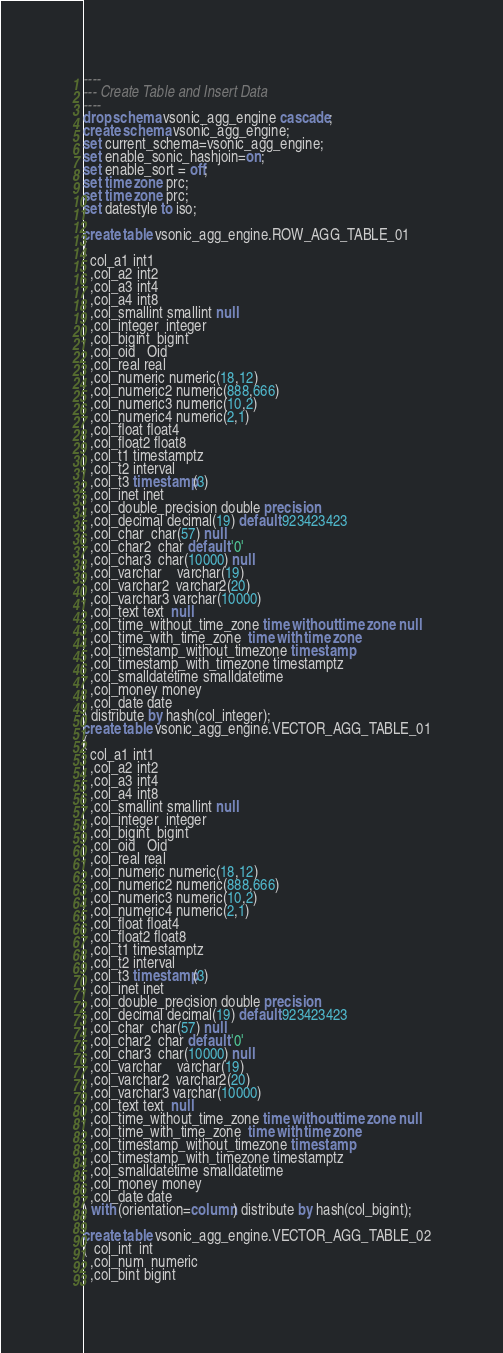<code> <loc_0><loc_0><loc_500><loc_500><_SQL_>

----
--- Create Table and Insert Data
----
drop schema vsonic_agg_engine cascade;
create schema vsonic_agg_engine;
set current_schema=vsonic_agg_engine;
set enable_sonic_hashjoin=on;
set enable_sort = off;
set time zone prc;
set time zone prc;
set datestyle to iso;

create table vsonic_agg_engine.ROW_AGG_TABLE_01
( 
  col_a1 int1
  ,col_a2 int2
  ,col_a3 int4
  ,col_a4 int8
  ,col_smallint smallint null
  ,col_integer  integer  
  ,col_bigint  bigint  
  ,col_oid   Oid
  ,col_real real 
  ,col_numeric numeric(18,12) 
  ,col_numeric2 numeric(888,666) 
  ,col_numeric3 numeric(10,2) 
  ,col_numeric4 numeric(2,1) 
  ,col_float float4
  ,col_float2 float8
  ,col_t1 timestamptz
  ,col_t2 interval
  ,col_t3 timestamp(3)
  ,col_inet inet
  ,col_double_precision double precision
  ,col_decimal decimal(19) default 923423423
  ,col_char  char(57) null
  ,col_char2  char default '0'
  ,col_char3  char(10000) null
  ,col_varchar 	varchar(19)
  ,col_varchar2  varchar2(20)
  ,col_varchar3 varchar(10000)
  ,col_text text  null
  ,col_time_without_time_zone time without time zone null
  ,col_time_with_time_zone  time with time zone
  ,col_timestamp_without_timezone timestamp
  ,col_timestamp_with_timezone timestamptz
  ,col_smalldatetime smalldatetime
  ,col_money money
  ,col_date date
) distribute by hash(col_integer);
create table vsonic_agg_engine.VECTOR_AGG_TABLE_01
( 
  col_a1 int1
  ,col_a2 int2
  ,col_a3 int4
  ,col_a4 int8
  ,col_smallint smallint null
  ,col_integer  integer  
  ,col_bigint  bigint  
  ,col_oid   Oid
  ,col_real real 
  ,col_numeric numeric(18,12) 
  ,col_numeric2 numeric(888,666) 
  ,col_numeric3 numeric(10,2) 
  ,col_numeric4 numeric(2,1) 
  ,col_float float4
  ,col_float2 float8
  ,col_t1 timestamptz
  ,col_t2 interval
  ,col_t3 timestamp(3)
  ,col_inet inet
  ,col_double_precision double precision
  ,col_decimal decimal(19) default 923423423
  ,col_char  char(57) null
  ,col_char2  char default '0'
  ,col_char3  char(10000) null
  ,col_varchar 	varchar(19)
  ,col_varchar2  varchar2(20)
  ,col_varchar3 varchar(10000)
  ,col_text text  null
  ,col_time_without_time_zone time without time zone null
  ,col_time_with_time_zone  time with time zone
  ,col_timestamp_without_timezone timestamp
  ,col_timestamp_with_timezone timestamptz
  ,col_smalldatetime smalldatetime
  ,col_money money
  ,col_date date
) with (orientation=column) distribute by hash(col_bigint);

create table vsonic_agg_engine.VECTOR_AGG_TABLE_02
(  col_int  int
  ,col_num  numeric
  ,col_bint bigint</code> 